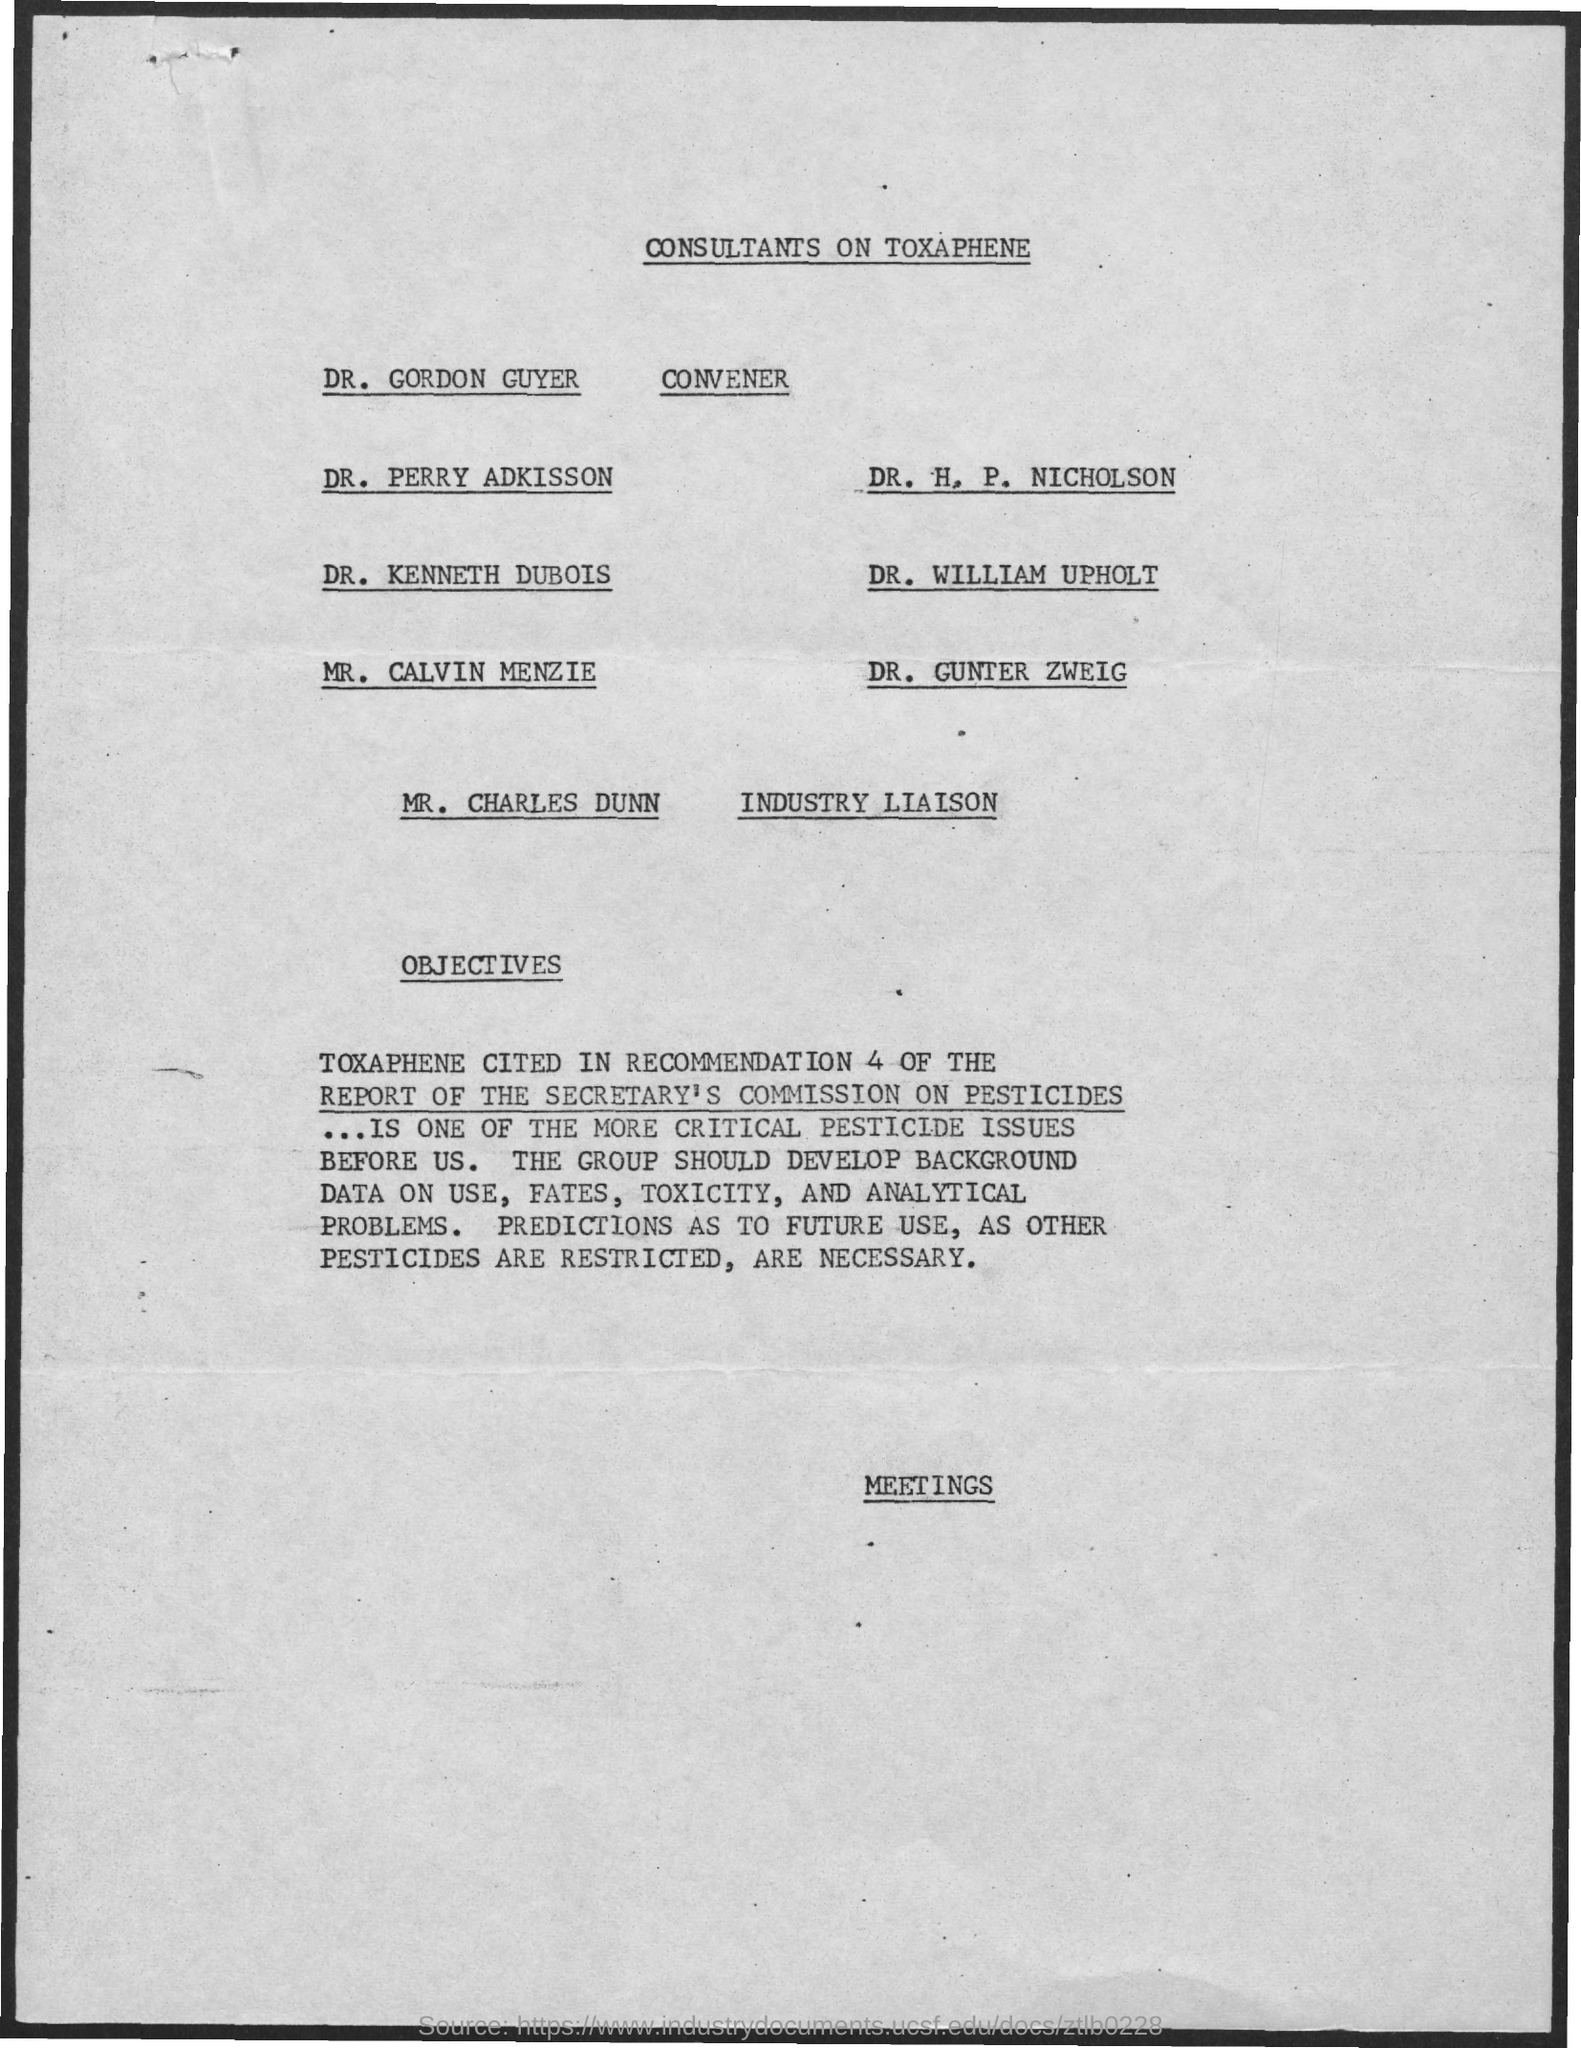Specify some key components in this picture. Dr. Gordon Guyer is the convener. The Industry Liaison is Mr. Charles Dunn. The title of the document is 'Consultants on Toxaphene.' 